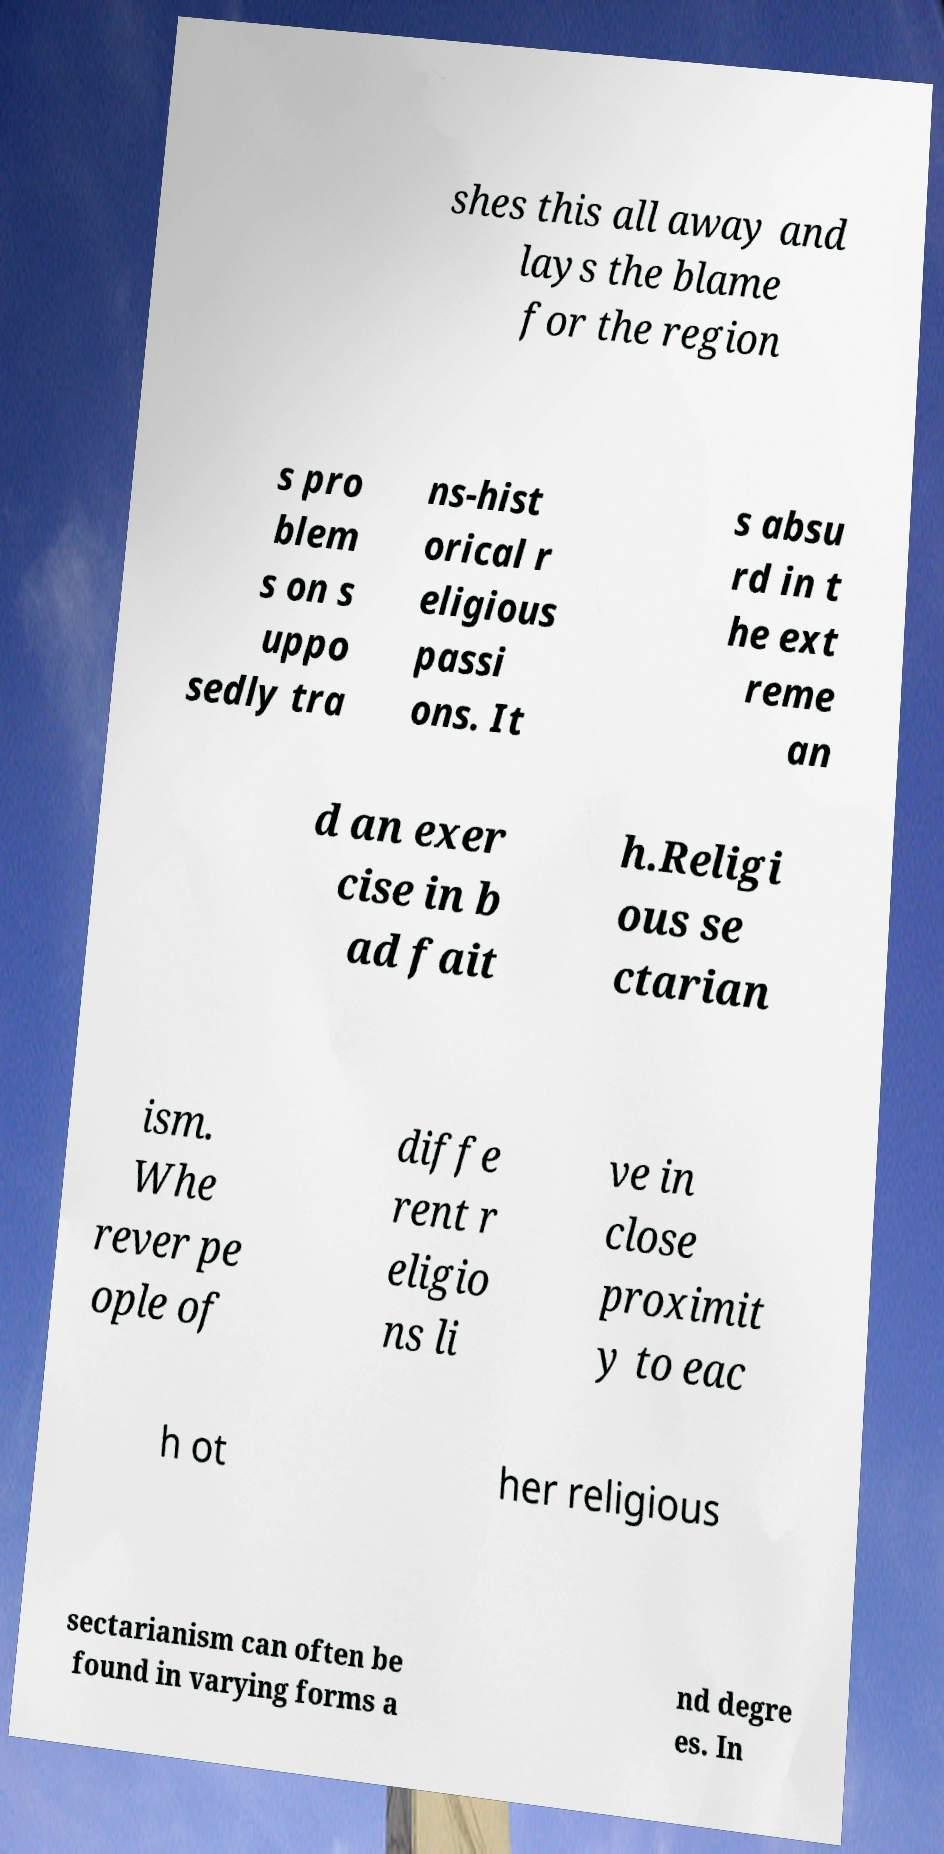There's text embedded in this image that I need extracted. Can you transcribe it verbatim? shes this all away and lays the blame for the region s pro blem s on s uppo sedly tra ns-hist orical r eligious passi ons. It s absu rd in t he ext reme an d an exer cise in b ad fait h.Religi ous se ctarian ism. Whe rever pe ople of diffe rent r eligio ns li ve in close proximit y to eac h ot her religious sectarianism can often be found in varying forms a nd degre es. In 